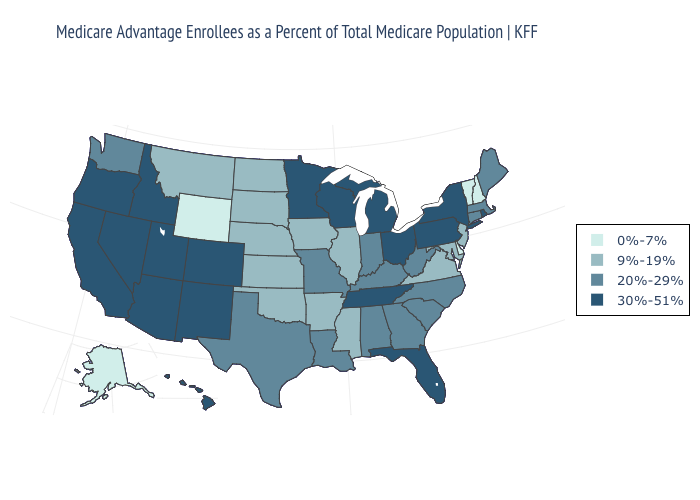What is the lowest value in states that border Oregon?
Write a very short answer. 20%-29%. How many symbols are there in the legend?
Concise answer only. 4. What is the highest value in the USA?
Write a very short answer. 30%-51%. What is the lowest value in the Northeast?
Give a very brief answer. 0%-7%. Does Idaho have the highest value in the West?
Short answer required. Yes. What is the highest value in the USA?
Be succinct. 30%-51%. Name the states that have a value in the range 9%-19%?
Keep it brief. Arkansas, Iowa, Illinois, Kansas, Maryland, Mississippi, Montana, North Dakota, Nebraska, New Jersey, Oklahoma, South Dakota, Virginia. What is the value of Hawaii?
Write a very short answer. 30%-51%. Does the map have missing data?
Write a very short answer. No. What is the lowest value in the South?
Quick response, please. 0%-7%. What is the lowest value in states that border Pennsylvania?
Quick response, please. 0%-7%. Among the states that border New Mexico , does Arizona have the lowest value?
Write a very short answer. No. Does New York have the lowest value in the Northeast?
Short answer required. No. Does Florida have the highest value in the USA?
Concise answer only. Yes. Does Connecticut have a higher value than Illinois?
Keep it brief. Yes. 